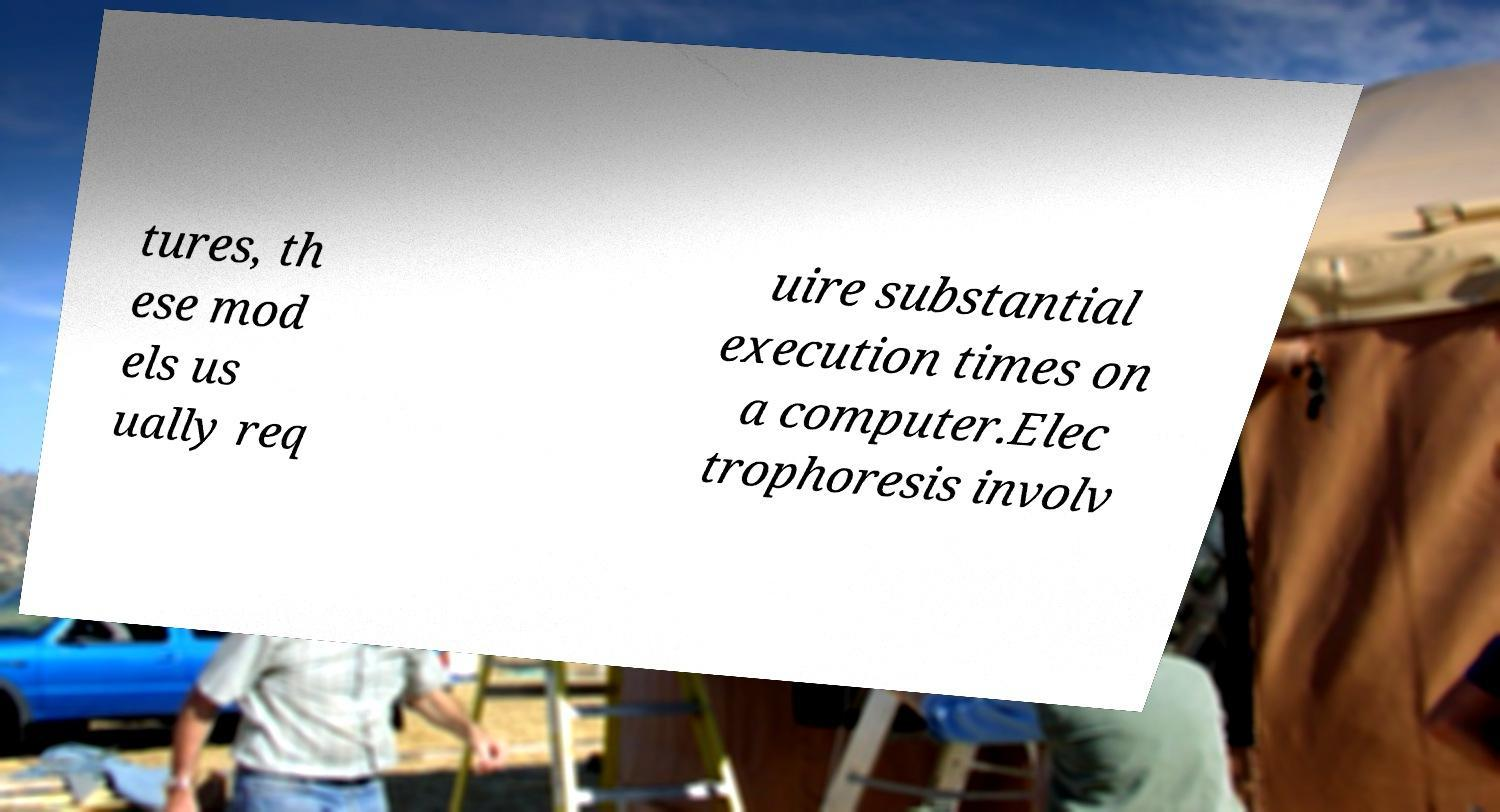Please identify and transcribe the text found in this image. tures, th ese mod els us ually req uire substantial execution times on a computer.Elec trophoresis involv 